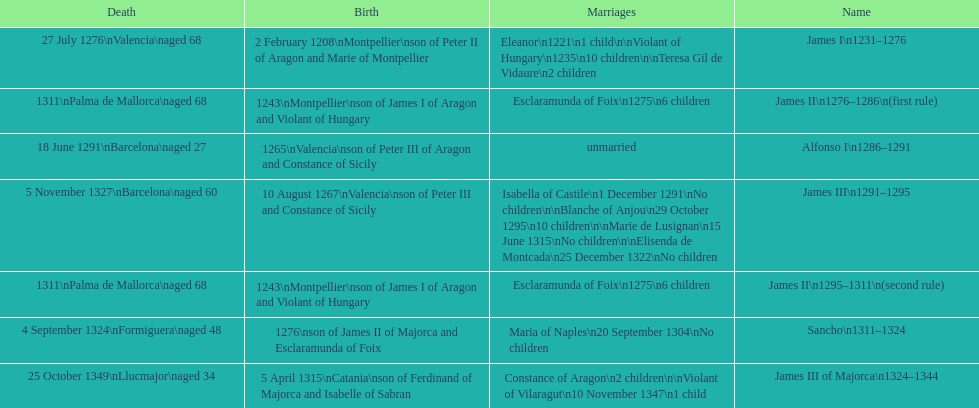Who came to power after the rule of james iii? James II. 